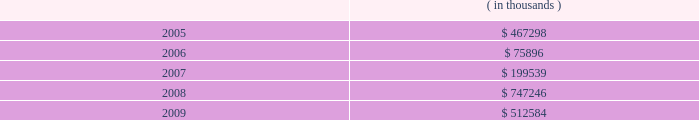Entergy corporation notes to consolidated financial statements the annual long-term debt maturities ( excluding lease obligations ) for debt outstanding as of december 31 , 2004 , for the next five years are as follows: .
In november 2000 , entergy's non-utility nuclear business purchased the fitzpatrick and indian point 3 power plants in a seller-financed transaction .
Entergy issued notes to nypa with seven annual installments of approximately $ 108 million commencing one year from the date of the closing , and eight annual installments of $ 20 million commencing eight years from the date of the closing .
These notes do not have a stated interest rate , but have an implicit interest rate of 4.8% ( 4.8 % ) .
In accordance with the purchase agreement with nypa , the purchase of indian point 2 in 2001 resulted in entergy's non-utility nuclear business becoming liable to nypa for an additional $ 10 million per year for 10 years , beginning in september 2003 .
This liability was recorded upon the purchase of indian point 2 in september 2001 , and is included in the note payable to nypa balance above .
In july 2003 , a payment of $ 102 million was made prior to maturity on the note payable to nypa .
Under a provision in a letter of credit supporting these notes , if certain of the domestic utility companies or system energy were to default on other indebtedness , entergy could be required to post collateral to support the letter of credit .
Covenants in the entergy corporation notes require it to maintain a consolidated debt ratio of 65% ( 65 % ) or less of its total capitalization .
If entergy's debt ratio exceeds this limit , or if entergy or certain of the domestic utility companies default on other indebtedness or are in bankruptcy or insolvency proceedings , an acceleration of the notes' maturity dates may occur .
The long-term securities issuances of entergy corporation , entergy gulf states , entergy louisiana , entergy mississippi , and system energy also are limited to amounts authorized by the sec .
Under its current sec order , and without further authorization , entergy corporation cannot incur additional indebtedness or issue other securities unless ( a ) it and each of its public utility subsidiaries maintain a common equity ratio of at least 30% ( 30 % ) and ( b ) the security to be issued ( if rated ) and all outstanding securities of entergy corporation that are rated , are rated investment grade by at least one nationally recognized statistical rating agency .
Under their current sec orders , and without further authorization , entergy gulf states , entergy louisiana , and entergy mississippi cannot incur additional indebtedness or issue other securities unless ( a ) the issuer and entergy corporation maintains a common equity ratio of at least 30% ( 30 % ) and ( b ) the security to be issued ( if rated ) and all outstanding securities of the issuer ( other than preferred stock of entergy gulf states ) , as well as all outstanding securities of entergy corporation , that are rated , are rated investment grade .
Junior subordinated deferrable interest debentures and implementation of fin 46 entergy implemented fasb interpretation no .
46 , "consolidation of variable interest entities" effective december 31 , 2003 .
Fin 46 requires existing unconsolidated variable interest entities to be consolidated by their primary beneficiaries if the entities do not effectively disperse risks among their investors .
Variable interest entities ( vies ) , generally , are entities that do not have sufficient equity to permit the entity to finance its operations without additional financial support from its equity interest holders and/or the group of equity interest holders are collectively not able to exercise control over the entity .
The primary beneficiary is the party that absorbs a majority of the entity's expected losses , receives a majority of its expected residual returns , or both as a result of holding the variable interest .
A company may have an interest in a vie through ownership or other contractual rights or obligations .
Entergy louisiana capital i , entergy arkansas capital i , and entergy gulf states capital i ( trusts ) were established as financing subsidiaries of entergy louisiana , entergy arkansas , and entergy gulf states .
What amount of long-term debt is due in the next 24 months for entergy corporation as of december 31 , 2004 , in millions? 
Computations: ((467298 + 75896) / 1000)
Answer: 543.194. 